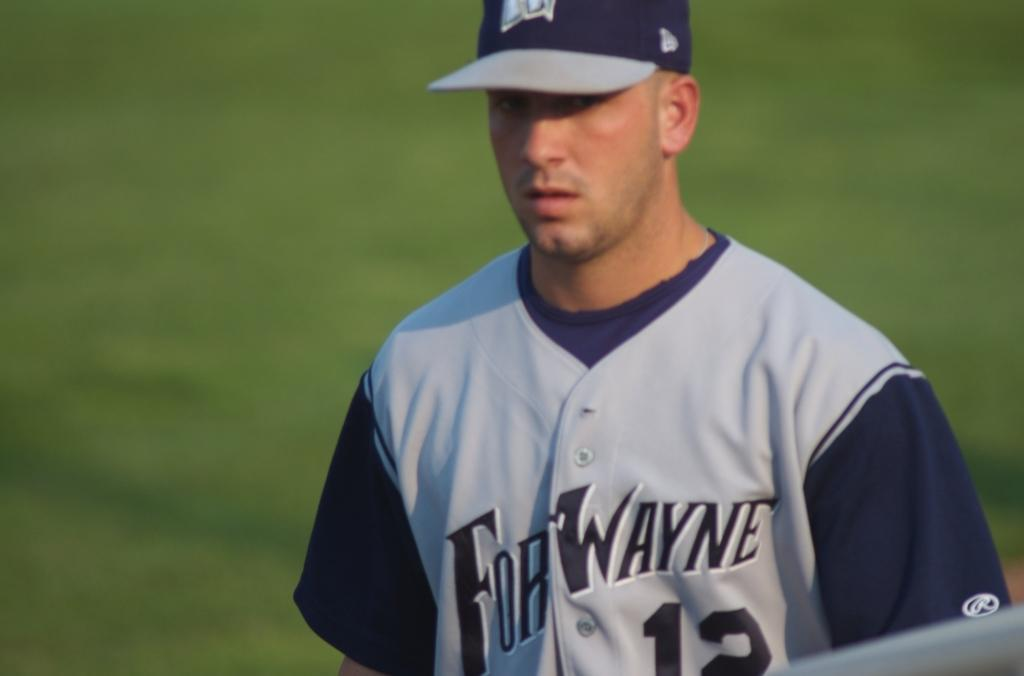<image>
Write a terse but informative summary of the picture. a baseball player in a blue and grey uniform that reads fort wayne on his chest. 